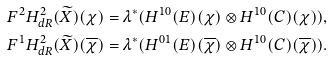<formula> <loc_0><loc_0><loc_500><loc_500>& F ^ { 2 } H _ { d R } ^ { 2 } ( \widetilde { X } ) ( \chi ) = \lambda ^ { * } ( H ^ { 1 0 } ( E ) ( \chi ) \otimes H ^ { 1 0 } ( C ) ( \chi ) ) , \\ & F ^ { 1 } H _ { d R } ^ { 2 } ( \widetilde { X } ) ( \overline { \chi } ) = \lambda ^ { * } ( H ^ { 0 1 } ( E ) ( \overline { \chi } ) \otimes H ^ { 1 0 } ( C ) ( \overline { \chi } ) ) .</formula> 